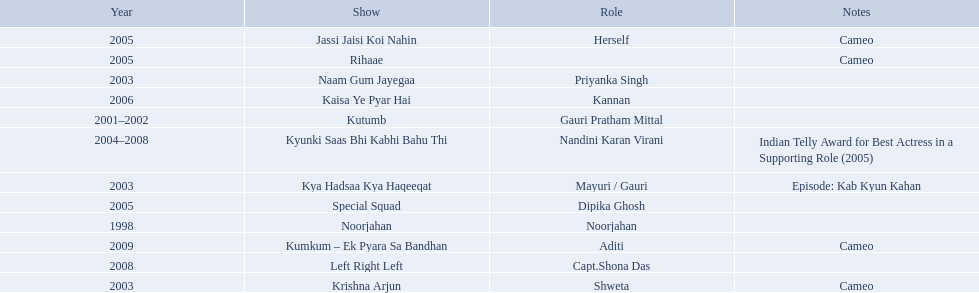What shows did gauri pradhan tejwani star in? Noorjahan, Kutumb, Krishna Arjun, Naam Gum Jayegaa, Kya Hadsaa Kya Haqeeqat, Kyunki Saas Bhi Kabhi Bahu Thi, Rihaae, Jassi Jaisi Koi Nahin, Special Squad, Kaisa Ye Pyar Hai, Left Right Left, Kumkum – Ek Pyara Sa Bandhan. Of these, which were cameos? Krishna Arjun, Rihaae, Jassi Jaisi Koi Nahin, Kumkum – Ek Pyara Sa Bandhan. Of these, in which did she play the role of herself? Jassi Jaisi Koi Nahin. In 1998 what was the role of gauri pradhan tejwani? Noorjahan. In 2003 what show did gauri have a cameo in? Krishna Arjun. Gauri was apart of which television show for the longest? Kyunki Saas Bhi Kabhi Bahu Thi. 